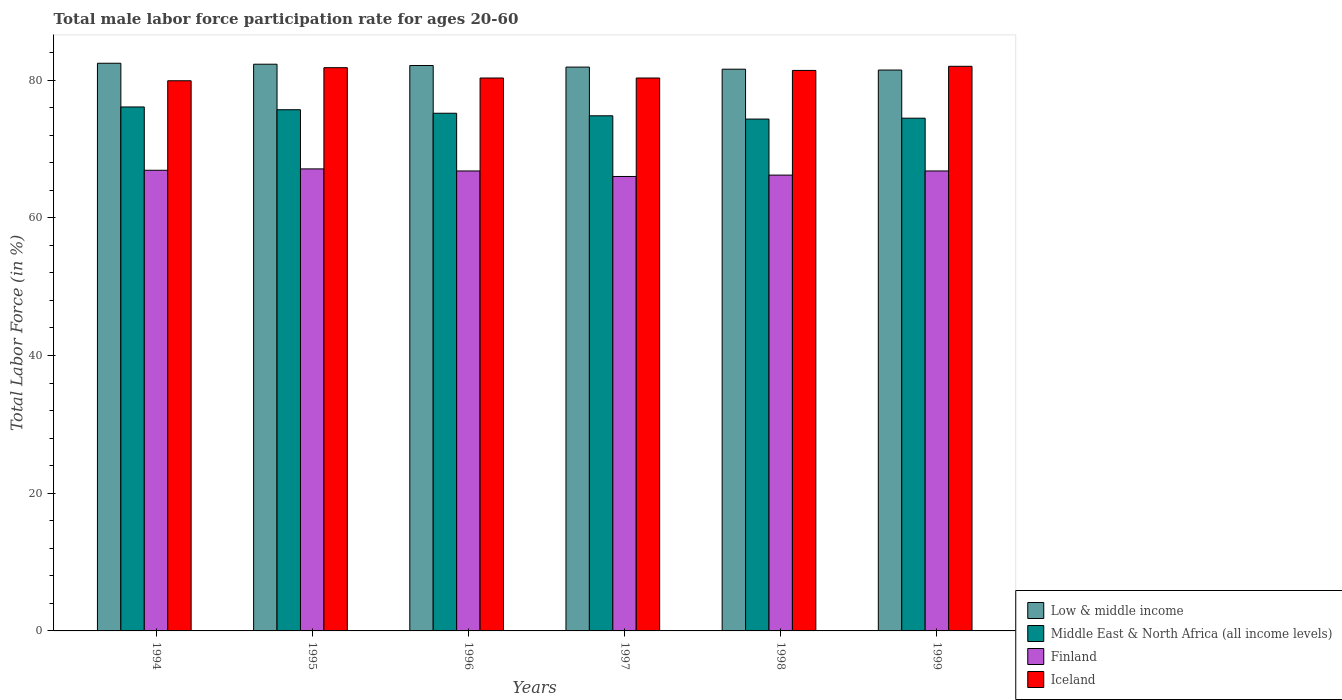How many different coloured bars are there?
Ensure brevity in your answer.  4. How many groups of bars are there?
Your response must be concise. 6. What is the male labor force participation rate in Iceland in 1997?
Offer a terse response. 80.3. Across all years, what is the maximum male labor force participation rate in Finland?
Give a very brief answer. 67.1. Across all years, what is the minimum male labor force participation rate in Iceland?
Offer a terse response. 79.9. In which year was the male labor force participation rate in Finland maximum?
Provide a short and direct response. 1995. What is the total male labor force participation rate in Middle East & North Africa (all income levels) in the graph?
Offer a terse response. 450.58. What is the difference between the male labor force participation rate in Middle East & North Africa (all income levels) in 1995 and that in 1996?
Offer a very short reply. 0.51. What is the difference between the male labor force participation rate in Middle East & North Africa (all income levels) in 1996 and the male labor force participation rate in Finland in 1995?
Offer a very short reply. 8.08. What is the average male labor force participation rate in Iceland per year?
Your answer should be compact. 80.95. In the year 1994, what is the difference between the male labor force participation rate in Iceland and male labor force participation rate in Middle East & North Africa (all income levels)?
Your response must be concise. 3.8. What is the ratio of the male labor force participation rate in Middle East & North Africa (all income levels) in 1996 to that in 1999?
Your answer should be very brief. 1.01. What is the difference between the highest and the second highest male labor force participation rate in Middle East & North Africa (all income levels)?
Provide a short and direct response. 0.4. What is the difference between the highest and the lowest male labor force participation rate in Middle East & North Africa (all income levels)?
Offer a very short reply. 1.76. Is the sum of the male labor force participation rate in Finland in 1998 and 1999 greater than the maximum male labor force participation rate in Middle East & North Africa (all income levels) across all years?
Give a very brief answer. Yes. Is it the case that in every year, the sum of the male labor force participation rate in Finland and male labor force participation rate in Iceland is greater than the sum of male labor force participation rate in Middle East & North Africa (all income levels) and male labor force participation rate in Low & middle income?
Keep it short and to the point. No. What does the 2nd bar from the left in 1995 represents?
Give a very brief answer. Middle East & North Africa (all income levels). What does the 1st bar from the right in 1996 represents?
Make the answer very short. Iceland. How many bars are there?
Ensure brevity in your answer.  24. Are all the bars in the graph horizontal?
Your response must be concise. No. How many years are there in the graph?
Give a very brief answer. 6. What is the difference between two consecutive major ticks on the Y-axis?
Make the answer very short. 20. Are the values on the major ticks of Y-axis written in scientific E-notation?
Offer a terse response. No. Does the graph contain any zero values?
Your answer should be very brief. No. Does the graph contain grids?
Offer a very short reply. No. Where does the legend appear in the graph?
Provide a succinct answer. Bottom right. How many legend labels are there?
Your answer should be compact. 4. How are the legend labels stacked?
Ensure brevity in your answer.  Vertical. What is the title of the graph?
Offer a terse response. Total male labor force participation rate for ages 20-60. Does "Uzbekistan" appear as one of the legend labels in the graph?
Provide a short and direct response. No. What is the Total Labor Force (in %) in Low & middle income in 1994?
Provide a succinct answer. 82.44. What is the Total Labor Force (in %) of Middle East & North Africa (all income levels) in 1994?
Make the answer very short. 76.1. What is the Total Labor Force (in %) of Finland in 1994?
Give a very brief answer. 66.9. What is the Total Labor Force (in %) in Iceland in 1994?
Make the answer very short. 79.9. What is the Total Labor Force (in %) of Low & middle income in 1995?
Make the answer very short. 82.3. What is the Total Labor Force (in %) in Middle East & North Africa (all income levels) in 1995?
Your answer should be compact. 75.69. What is the Total Labor Force (in %) in Finland in 1995?
Ensure brevity in your answer.  67.1. What is the Total Labor Force (in %) of Iceland in 1995?
Ensure brevity in your answer.  81.8. What is the Total Labor Force (in %) of Low & middle income in 1996?
Your answer should be compact. 82.12. What is the Total Labor Force (in %) in Middle East & North Africa (all income levels) in 1996?
Offer a very short reply. 75.18. What is the Total Labor Force (in %) of Finland in 1996?
Your response must be concise. 66.8. What is the Total Labor Force (in %) of Iceland in 1996?
Make the answer very short. 80.3. What is the Total Labor Force (in %) in Low & middle income in 1997?
Your response must be concise. 81.89. What is the Total Labor Force (in %) in Middle East & North Africa (all income levels) in 1997?
Offer a terse response. 74.81. What is the Total Labor Force (in %) in Finland in 1997?
Your response must be concise. 66. What is the Total Labor Force (in %) of Iceland in 1997?
Provide a succinct answer. 80.3. What is the Total Labor Force (in %) of Low & middle income in 1998?
Your response must be concise. 81.58. What is the Total Labor Force (in %) of Middle East & North Africa (all income levels) in 1998?
Provide a short and direct response. 74.34. What is the Total Labor Force (in %) in Finland in 1998?
Your answer should be compact. 66.2. What is the Total Labor Force (in %) of Iceland in 1998?
Provide a short and direct response. 81.4. What is the Total Labor Force (in %) in Low & middle income in 1999?
Offer a very short reply. 81.46. What is the Total Labor Force (in %) in Middle East & North Africa (all income levels) in 1999?
Offer a terse response. 74.46. What is the Total Labor Force (in %) of Finland in 1999?
Keep it short and to the point. 66.8. Across all years, what is the maximum Total Labor Force (in %) of Low & middle income?
Ensure brevity in your answer.  82.44. Across all years, what is the maximum Total Labor Force (in %) in Middle East & North Africa (all income levels)?
Give a very brief answer. 76.1. Across all years, what is the maximum Total Labor Force (in %) in Finland?
Give a very brief answer. 67.1. Across all years, what is the minimum Total Labor Force (in %) of Low & middle income?
Keep it short and to the point. 81.46. Across all years, what is the minimum Total Labor Force (in %) of Middle East & North Africa (all income levels)?
Give a very brief answer. 74.34. Across all years, what is the minimum Total Labor Force (in %) of Finland?
Your response must be concise. 66. Across all years, what is the minimum Total Labor Force (in %) in Iceland?
Your answer should be very brief. 79.9. What is the total Total Labor Force (in %) of Low & middle income in the graph?
Provide a short and direct response. 491.79. What is the total Total Labor Force (in %) in Middle East & North Africa (all income levels) in the graph?
Your answer should be compact. 450.58. What is the total Total Labor Force (in %) of Finland in the graph?
Offer a terse response. 399.8. What is the total Total Labor Force (in %) in Iceland in the graph?
Give a very brief answer. 485.7. What is the difference between the Total Labor Force (in %) in Low & middle income in 1994 and that in 1995?
Keep it short and to the point. 0.14. What is the difference between the Total Labor Force (in %) of Middle East & North Africa (all income levels) in 1994 and that in 1995?
Your answer should be compact. 0.4. What is the difference between the Total Labor Force (in %) in Finland in 1994 and that in 1995?
Your answer should be compact. -0.2. What is the difference between the Total Labor Force (in %) of Iceland in 1994 and that in 1995?
Your answer should be very brief. -1.9. What is the difference between the Total Labor Force (in %) in Low & middle income in 1994 and that in 1996?
Provide a succinct answer. 0.33. What is the difference between the Total Labor Force (in %) of Middle East & North Africa (all income levels) in 1994 and that in 1996?
Give a very brief answer. 0.91. What is the difference between the Total Labor Force (in %) in Iceland in 1994 and that in 1996?
Keep it short and to the point. -0.4. What is the difference between the Total Labor Force (in %) in Low & middle income in 1994 and that in 1997?
Your answer should be very brief. 0.56. What is the difference between the Total Labor Force (in %) of Middle East & North Africa (all income levels) in 1994 and that in 1997?
Give a very brief answer. 1.28. What is the difference between the Total Labor Force (in %) in Finland in 1994 and that in 1997?
Keep it short and to the point. 0.9. What is the difference between the Total Labor Force (in %) in Iceland in 1994 and that in 1997?
Offer a terse response. -0.4. What is the difference between the Total Labor Force (in %) in Low & middle income in 1994 and that in 1998?
Offer a terse response. 0.86. What is the difference between the Total Labor Force (in %) in Middle East & North Africa (all income levels) in 1994 and that in 1998?
Make the answer very short. 1.76. What is the difference between the Total Labor Force (in %) of Finland in 1994 and that in 1998?
Provide a short and direct response. 0.7. What is the difference between the Total Labor Force (in %) in Low & middle income in 1994 and that in 1999?
Offer a very short reply. 0.99. What is the difference between the Total Labor Force (in %) of Middle East & North Africa (all income levels) in 1994 and that in 1999?
Offer a terse response. 1.63. What is the difference between the Total Labor Force (in %) of Finland in 1994 and that in 1999?
Your answer should be compact. 0.1. What is the difference between the Total Labor Force (in %) of Low & middle income in 1995 and that in 1996?
Provide a succinct answer. 0.19. What is the difference between the Total Labor Force (in %) of Middle East & North Africa (all income levels) in 1995 and that in 1996?
Give a very brief answer. 0.51. What is the difference between the Total Labor Force (in %) in Finland in 1995 and that in 1996?
Give a very brief answer. 0.3. What is the difference between the Total Labor Force (in %) in Iceland in 1995 and that in 1996?
Provide a short and direct response. 1.5. What is the difference between the Total Labor Force (in %) of Low & middle income in 1995 and that in 1997?
Make the answer very short. 0.42. What is the difference between the Total Labor Force (in %) in Middle East & North Africa (all income levels) in 1995 and that in 1997?
Your answer should be very brief. 0.88. What is the difference between the Total Labor Force (in %) in Iceland in 1995 and that in 1997?
Offer a terse response. 1.5. What is the difference between the Total Labor Force (in %) of Low & middle income in 1995 and that in 1998?
Provide a short and direct response. 0.72. What is the difference between the Total Labor Force (in %) in Middle East & North Africa (all income levels) in 1995 and that in 1998?
Keep it short and to the point. 1.36. What is the difference between the Total Labor Force (in %) of Low & middle income in 1995 and that in 1999?
Give a very brief answer. 0.85. What is the difference between the Total Labor Force (in %) of Middle East & North Africa (all income levels) in 1995 and that in 1999?
Your answer should be very brief. 1.23. What is the difference between the Total Labor Force (in %) of Low & middle income in 1996 and that in 1997?
Keep it short and to the point. 0.23. What is the difference between the Total Labor Force (in %) of Middle East & North Africa (all income levels) in 1996 and that in 1997?
Give a very brief answer. 0.37. What is the difference between the Total Labor Force (in %) in Finland in 1996 and that in 1997?
Give a very brief answer. 0.8. What is the difference between the Total Labor Force (in %) of Iceland in 1996 and that in 1997?
Keep it short and to the point. 0. What is the difference between the Total Labor Force (in %) of Low & middle income in 1996 and that in 1998?
Your answer should be very brief. 0.54. What is the difference between the Total Labor Force (in %) in Middle East & North Africa (all income levels) in 1996 and that in 1998?
Your response must be concise. 0.85. What is the difference between the Total Labor Force (in %) of Finland in 1996 and that in 1998?
Make the answer very short. 0.6. What is the difference between the Total Labor Force (in %) of Low & middle income in 1996 and that in 1999?
Your response must be concise. 0.66. What is the difference between the Total Labor Force (in %) of Middle East & North Africa (all income levels) in 1996 and that in 1999?
Your answer should be compact. 0.72. What is the difference between the Total Labor Force (in %) of Iceland in 1996 and that in 1999?
Your answer should be compact. -1.7. What is the difference between the Total Labor Force (in %) of Low & middle income in 1997 and that in 1998?
Your response must be concise. 0.31. What is the difference between the Total Labor Force (in %) of Middle East & North Africa (all income levels) in 1997 and that in 1998?
Ensure brevity in your answer.  0.48. What is the difference between the Total Labor Force (in %) in Iceland in 1997 and that in 1998?
Make the answer very short. -1.1. What is the difference between the Total Labor Force (in %) of Low & middle income in 1997 and that in 1999?
Provide a succinct answer. 0.43. What is the difference between the Total Labor Force (in %) in Middle East & North Africa (all income levels) in 1997 and that in 1999?
Offer a very short reply. 0.35. What is the difference between the Total Labor Force (in %) of Finland in 1997 and that in 1999?
Keep it short and to the point. -0.8. What is the difference between the Total Labor Force (in %) of Iceland in 1997 and that in 1999?
Provide a succinct answer. -1.7. What is the difference between the Total Labor Force (in %) of Low & middle income in 1998 and that in 1999?
Offer a very short reply. 0.12. What is the difference between the Total Labor Force (in %) of Middle East & North Africa (all income levels) in 1998 and that in 1999?
Keep it short and to the point. -0.13. What is the difference between the Total Labor Force (in %) of Finland in 1998 and that in 1999?
Your response must be concise. -0.6. What is the difference between the Total Labor Force (in %) in Low & middle income in 1994 and the Total Labor Force (in %) in Middle East & North Africa (all income levels) in 1995?
Offer a very short reply. 6.75. What is the difference between the Total Labor Force (in %) in Low & middle income in 1994 and the Total Labor Force (in %) in Finland in 1995?
Your answer should be compact. 15.34. What is the difference between the Total Labor Force (in %) in Low & middle income in 1994 and the Total Labor Force (in %) in Iceland in 1995?
Make the answer very short. 0.64. What is the difference between the Total Labor Force (in %) of Middle East & North Africa (all income levels) in 1994 and the Total Labor Force (in %) of Finland in 1995?
Ensure brevity in your answer.  9. What is the difference between the Total Labor Force (in %) in Middle East & North Africa (all income levels) in 1994 and the Total Labor Force (in %) in Iceland in 1995?
Your answer should be very brief. -5.7. What is the difference between the Total Labor Force (in %) of Finland in 1994 and the Total Labor Force (in %) of Iceland in 1995?
Your answer should be very brief. -14.9. What is the difference between the Total Labor Force (in %) in Low & middle income in 1994 and the Total Labor Force (in %) in Middle East & North Africa (all income levels) in 1996?
Make the answer very short. 7.26. What is the difference between the Total Labor Force (in %) of Low & middle income in 1994 and the Total Labor Force (in %) of Finland in 1996?
Ensure brevity in your answer.  15.64. What is the difference between the Total Labor Force (in %) of Low & middle income in 1994 and the Total Labor Force (in %) of Iceland in 1996?
Provide a succinct answer. 2.14. What is the difference between the Total Labor Force (in %) of Middle East & North Africa (all income levels) in 1994 and the Total Labor Force (in %) of Finland in 1996?
Provide a short and direct response. 9.3. What is the difference between the Total Labor Force (in %) in Middle East & North Africa (all income levels) in 1994 and the Total Labor Force (in %) in Iceland in 1996?
Offer a terse response. -4.2. What is the difference between the Total Labor Force (in %) in Low & middle income in 1994 and the Total Labor Force (in %) in Middle East & North Africa (all income levels) in 1997?
Offer a very short reply. 7.63. What is the difference between the Total Labor Force (in %) of Low & middle income in 1994 and the Total Labor Force (in %) of Finland in 1997?
Keep it short and to the point. 16.44. What is the difference between the Total Labor Force (in %) in Low & middle income in 1994 and the Total Labor Force (in %) in Iceland in 1997?
Your answer should be very brief. 2.14. What is the difference between the Total Labor Force (in %) in Middle East & North Africa (all income levels) in 1994 and the Total Labor Force (in %) in Finland in 1997?
Ensure brevity in your answer.  10.1. What is the difference between the Total Labor Force (in %) of Middle East & North Africa (all income levels) in 1994 and the Total Labor Force (in %) of Iceland in 1997?
Give a very brief answer. -4.2. What is the difference between the Total Labor Force (in %) in Low & middle income in 1994 and the Total Labor Force (in %) in Middle East & North Africa (all income levels) in 1998?
Give a very brief answer. 8.11. What is the difference between the Total Labor Force (in %) of Low & middle income in 1994 and the Total Labor Force (in %) of Finland in 1998?
Offer a very short reply. 16.24. What is the difference between the Total Labor Force (in %) of Low & middle income in 1994 and the Total Labor Force (in %) of Iceland in 1998?
Offer a terse response. 1.04. What is the difference between the Total Labor Force (in %) of Middle East & North Africa (all income levels) in 1994 and the Total Labor Force (in %) of Finland in 1998?
Your answer should be compact. 9.9. What is the difference between the Total Labor Force (in %) of Middle East & North Africa (all income levels) in 1994 and the Total Labor Force (in %) of Iceland in 1998?
Your answer should be compact. -5.3. What is the difference between the Total Labor Force (in %) in Finland in 1994 and the Total Labor Force (in %) in Iceland in 1998?
Offer a terse response. -14.5. What is the difference between the Total Labor Force (in %) in Low & middle income in 1994 and the Total Labor Force (in %) in Middle East & North Africa (all income levels) in 1999?
Offer a terse response. 7.98. What is the difference between the Total Labor Force (in %) in Low & middle income in 1994 and the Total Labor Force (in %) in Finland in 1999?
Offer a terse response. 15.64. What is the difference between the Total Labor Force (in %) of Low & middle income in 1994 and the Total Labor Force (in %) of Iceland in 1999?
Your response must be concise. 0.44. What is the difference between the Total Labor Force (in %) in Middle East & North Africa (all income levels) in 1994 and the Total Labor Force (in %) in Finland in 1999?
Provide a succinct answer. 9.3. What is the difference between the Total Labor Force (in %) of Middle East & North Africa (all income levels) in 1994 and the Total Labor Force (in %) of Iceland in 1999?
Provide a succinct answer. -5.9. What is the difference between the Total Labor Force (in %) in Finland in 1994 and the Total Labor Force (in %) in Iceland in 1999?
Your response must be concise. -15.1. What is the difference between the Total Labor Force (in %) of Low & middle income in 1995 and the Total Labor Force (in %) of Middle East & North Africa (all income levels) in 1996?
Offer a very short reply. 7.12. What is the difference between the Total Labor Force (in %) of Low & middle income in 1995 and the Total Labor Force (in %) of Finland in 1996?
Keep it short and to the point. 15.5. What is the difference between the Total Labor Force (in %) in Low & middle income in 1995 and the Total Labor Force (in %) in Iceland in 1996?
Provide a short and direct response. 2. What is the difference between the Total Labor Force (in %) in Middle East & North Africa (all income levels) in 1995 and the Total Labor Force (in %) in Finland in 1996?
Offer a very short reply. 8.89. What is the difference between the Total Labor Force (in %) of Middle East & North Africa (all income levels) in 1995 and the Total Labor Force (in %) of Iceland in 1996?
Offer a terse response. -4.61. What is the difference between the Total Labor Force (in %) in Finland in 1995 and the Total Labor Force (in %) in Iceland in 1996?
Your answer should be compact. -13.2. What is the difference between the Total Labor Force (in %) in Low & middle income in 1995 and the Total Labor Force (in %) in Middle East & North Africa (all income levels) in 1997?
Ensure brevity in your answer.  7.49. What is the difference between the Total Labor Force (in %) of Low & middle income in 1995 and the Total Labor Force (in %) of Finland in 1997?
Your response must be concise. 16.3. What is the difference between the Total Labor Force (in %) in Low & middle income in 1995 and the Total Labor Force (in %) in Iceland in 1997?
Give a very brief answer. 2. What is the difference between the Total Labor Force (in %) in Middle East & North Africa (all income levels) in 1995 and the Total Labor Force (in %) in Finland in 1997?
Ensure brevity in your answer.  9.69. What is the difference between the Total Labor Force (in %) in Middle East & North Africa (all income levels) in 1995 and the Total Labor Force (in %) in Iceland in 1997?
Ensure brevity in your answer.  -4.61. What is the difference between the Total Labor Force (in %) of Low & middle income in 1995 and the Total Labor Force (in %) of Middle East & North Africa (all income levels) in 1998?
Provide a succinct answer. 7.97. What is the difference between the Total Labor Force (in %) in Low & middle income in 1995 and the Total Labor Force (in %) in Finland in 1998?
Offer a terse response. 16.1. What is the difference between the Total Labor Force (in %) of Low & middle income in 1995 and the Total Labor Force (in %) of Iceland in 1998?
Provide a succinct answer. 0.9. What is the difference between the Total Labor Force (in %) of Middle East & North Africa (all income levels) in 1995 and the Total Labor Force (in %) of Finland in 1998?
Keep it short and to the point. 9.49. What is the difference between the Total Labor Force (in %) of Middle East & North Africa (all income levels) in 1995 and the Total Labor Force (in %) of Iceland in 1998?
Your answer should be very brief. -5.71. What is the difference between the Total Labor Force (in %) in Finland in 1995 and the Total Labor Force (in %) in Iceland in 1998?
Give a very brief answer. -14.3. What is the difference between the Total Labor Force (in %) of Low & middle income in 1995 and the Total Labor Force (in %) of Middle East & North Africa (all income levels) in 1999?
Offer a terse response. 7.84. What is the difference between the Total Labor Force (in %) of Low & middle income in 1995 and the Total Labor Force (in %) of Finland in 1999?
Your answer should be compact. 15.5. What is the difference between the Total Labor Force (in %) in Low & middle income in 1995 and the Total Labor Force (in %) in Iceland in 1999?
Your answer should be very brief. 0.3. What is the difference between the Total Labor Force (in %) of Middle East & North Africa (all income levels) in 1995 and the Total Labor Force (in %) of Finland in 1999?
Ensure brevity in your answer.  8.89. What is the difference between the Total Labor Force (in %) of Middle East & North Africa (all income levels) in 1995 and the Total Labor Force (in %) of Iceland in 1999?
Your answer should be compact. -6.31. What is the difference between the Total Labor Force (in %) of Finland in 1995 and the Total Labor Force (in %) of Iceland in 1999?
Keep it short and to the point. -14.9. What is the difference between the Total Labor Force (in %) of Low & middle income in 1996 and the Total Labor Force (in %) of Middle East & North Africa (all income levels) in 1997?
Make the answer very short. 7.3. What is the difference between the Total Labor Force (in %) of Low & middle income in 1996 and the Total Labor Force (in %) of Finland in 1997?
Your answer should be very brief. 16.12. What is the difference between the Total Labor Force (in %) of Low & middle income in 1996 and the Total Labor Force (in %) of Iceland in 1997?
Make the answer very short. 1.82. What is the difference between the Total Labor Force (in %) in Middle East & North Africa (all income levels) in 1996 and the Total Labor Force (in %) in Finland in 1997?
Provide a short and direct response. 9.18. What is the difference between the Total Labor Force (in %) in Middle East & North Africa (all income levels) in 1996 and the Total Labor Force (in %) in Iceland in 1997?
Give a very brief answer. -5.12. What is the difference between the Total Labor Force (in %) of Low & middle income in 1996 and the Total Labor Force (in %) of Middle East & North Africa (all income levels) in 1998?
Give a very brief answer. 7.78. What is the difference between the Total Labor Force (in %) of Low & middle income in 1996 and the Total Labor Force (in %) of Finland in 1998?
Offer a very short reply. 15.92. What is the difference between the Total Labor Force (in %) in Low & middle income in 1996 and the Total Labor Force (in %) in Iceland in 1998?
Make the answer very short. 0.72. What is the difference between the Total Labor Force (in %) in Middle East & North Africa (all income levels) in 1996 and the Total Labor Force (in %) in Finland in 1998?
Your answer should be compact. 8.98. What is the difference between the Total Labor Force (in %) of Middle East & North Africa (all income levels) in 1996 and the Total Labor Force (in %) of Iceland in 1998?
Your answer should be very brief. -6.22. What is the difference between the Total Labor Force (in %) of Finland in 1996 and the Total Labor Force (in %) of Iceland in 1998?
Ensure brevity in your answer.  -14.6. What is the difference between the Total Labor Force (in %) in Low & middle income in 1996 and the Total Labor Force (in %) in Middle East & North Africa (all income levels) in 1999?
Provide a short and direct response. 7.65. What is the difference between the Total Labor Force (in %) in Low & middle income in 1996 and the Total Labor Force (in %) in Finland in 1999?
Provide a short and direct response. 15.32. What is the difference between the Total Labor Force (in %) of Low & middle income in 1996 and the Total Labor Force (in %) of Iceland in 1999?
Make the answer very short. 0.12. What is the difference between the Total Labor Force (in %) of Middle East & North Africa (all income levels) in 1996 and the Total Labor Force (in %) of Finland in 1999?
Your response must be concise. 8.38. What is the difference between the Total Labor Force (in %) of Middle East & North Africa (all income levels) in 1996 and the Total Labor Force (in %) of Iceland in 1999?
Your answer should be very brief. -6.82. What is the difference between the Total Labor Force (in %) in Finland in 1996 and the Total Labor Force (in %) in Iceland in 1999?
Give a very brief answer. -15.2. What is the difference between the Total Labor Force (in %) of Low & middle income in 1997 and the Total Labor Force (in %) of Middle East & North Africa (all income levels) in 1998?
Keep it short and to the point. 7.55. What is the difference between the Total Labor Force (in %) of Low & middle income in 1997 and the Total Labor Force (in %) of Finland in 1998?
Ensure brevity in your answer.  15.69. What is the difference between the Total Labor Force (in %) in Low & middle income in 1997 and the Total Labor Force (in %) in Iceland in 1998?
Your answer should be compact. 0.49. What is the difference between the Total Labor Force (in %) of Middle East & North Africa (all income levels) in 1997 and the Total Labor Force (in %) of Finland in 1998?
Provide a short and direct response. 8.61. What is the difference between the Total Labor Force (in %) in Middle East & North Africa (all income levels) in 1997 and the Total Labor Force (in %) in Iceland in 1998?
Keep it short and to the point. -6.59. What is the difference between the Total Labor Force (in %) of Finland in 1997 and the Total Labor Force (in %) of Iceland in 1998?
Keep it short and to the point. -15.4. What is the difference between the Total Labor Force (in %) in Low & middle income in 1997 and the Total Labor Force (in %) in Middle East & North Africa (all income levels) in 1999?
Keep it short and to the point. 7.42. What is the difference between the Total Labor Force (in %) of Low & middle income in 1997 and the Total Labor Force (in %) of Finland in 1999?
Provide a short and direct response. 15.09. What is the difference between the Total Labor Force (in %) of Low & middle income in 1997 and the Total Labor Force (in %) of Iceland in 1999?
Your answer should be very brief. -0.11. What is the difference between the Total Labor Force (in %) in Middle East & North Africa (all income levels) in 1997 and the Total Labor Force (in %) in Finland in 1999?
Offer a terse response. 8.01. What is the difference between the Total Labor Force (in %) in Middle East & North Africa (all income levels) in 1997 and the Total Labor Force (in %) in Iceland in 1999?
Provide a succinct answer. -7.19. What is the difference between the Total Labor Force (in %) of Low & middle income in 1998 and the Total Labor Force (in %) of Middle East & North Africa (all income levels) in 1999?
Offer a terse response. 7.12. What is the difference between the Total Labor Force (in %) in Low & middle income in 1998 and the Total Labor Force (in %) in Finland in 1999?
Ensure brevity in your answer.  14.78. What is the difference between the Total Labor Force (in %) in Low & middle income in 1998 and the Total Labor Force (in %) in Iceland in 1999?
Provide a short and direct response. -0.42. What is the difference between the Total Labor Force (in %) of Middle East & North Africa (all income levels) in 1998 and the Total Labor Force (in %) of Finland in 1999?
Provide a succinct answer. 7.54. What is the difference between the Total Labor Force (in %) of Middle East & North Africa (all income levels) in 1998 and the Total Labor Force (in %) of Iceland in 1999?
Your answer should be very brief. -7.66. What is the difference between the Total Labor Force (in %) of Finland in 1998 and the Total Labor Force (in %) of Iceland in 1999?
Offer a terse response. -15.8. What is the average Total Labor Force (in %) in Low & middle income per year?
Provide a short and direct response. 81.96. What is the average Total Labor Force (in %) of Middle East & North Africa (all income levels) per year?
Offer a terse response. 75.1. What is the average Total Labor Force (in %) of Finland per year?
Keep it short and to the point. 66.63. What is the average Total Labor Force (in %) of Iceland per year?
Give a very brief answer. 80.95. In the year 1994, what is the difference between the Total Labor Force (in %) of Low & middle income and Total Labor Force (in %) of Middle East & North Africa (all income levels)?
Your answer should be very brief. 6.35. In the year 1994, what is the difference between the Total Labor Force (in %) in Low & middle income and Total Labor Force (in %) in Finland?
Offer a very short reply. 15.54. In the year 1994, what is the difference between the Total Labor Force (in %) in Low & middle income and Total Labor Force (in %) in Iceland?
Keep it short and to the point. 2.54. In the year 1994, what is the difference between the Total Labor Force (in %) in Middle East & North Africa (all income levels) and Total Labor Force (in %) in Finland?
Your answer should be compact. 9.2. In the year 1994, what is the difference between the Total Labor Force (in %) of Middle East & North Africa (all income levels) and Total Labor Force (in %) of Iceland?
Keep it short and to the point. -3.8. In the year 1995, what is the difference between the Total Labor Force (in %) of Low & middle income and Total Labor Force (in %) of Middle East & North Africa (all income levels)?
Your answer should be very brief. 6.61. In the year 1995, what is the difference between the Total Labor Force (in %) in Low & middle income and Total Labor Force (in %) in Finland?
Your answer should be very brief. 15.2. In the year 1995, what is the difference between the Total Labor Force (in %) of Low & middle income and Total Labor Force (in %) of Iceland?
Offer a very short reply. 0.5. In the year 1995, what is the difference between the Total Labor Force (in %) in Middle East & North Africa (all income levels) and Total Labor Force (in %) in Finland?
Offer a terse response. 8.59. In the year 1995, what is the difference between the Total Labor Force (in %) of Middle East & North Africa (all income levels) and Total Labor Force (in %) of Iceland?
Your response must be concise. -6.11. In the year 1995, what is the difference between the Total Labor Force (in %) in Finland and Total Labor Force (in %) in Iceland?
Offer a very short reply. -14.7. In the year 1996, what is the difference between the Total Labor Force (in %) of Low & middle income and Total Labor Force (in %) of Middle East & North Africa (all income levels)?
Make the answer very short. 6.93. In the year 1996, what is the difference between the Total Labor Force (in %) of Low & middle income and Total Labor Force (in %) of Finland?
Provide a short and direct response. 15.32. In the year 1996, what is the difference between the Total Labor Force (in %) in Low & middle income and Total Labor Force (in %) in Iceland?
Offer a very short reply. 1.82. In the year 1996, what is the difference between the Total Labor Force (in %) in Middle East & North Africa (all income levels) and Total Labor Force (in %) in Finland?
Ensure brevity in your answer.  8.38. In the year 1996, what is the difference between the Total Labor Force (in %) of Middle East & North Africa (all income levels) and Total Labor Force (in %) of Iceland?
Offer a very short reply. -5.12. In the year 1996, what is the difference between the Total Labor Force (in %) of Finland and Total Labor Force (in %) of Iceland?
Keep it short and to the point. -13.5. In the year 1997, what is the difference between the Total Labor Force (in %) of Low & middle income and Total Labor Force (in %) of Middle East & North Africa (all income levels)?
Make the answer very short. 7.07. In the year 1997, what is the difference between the Total Labor Force (in %) of Low & middle income and Total Labor Force (in %) of Finland?
Keep it short and to the point. 15.89. In the year 1997, what is the difference between the Total Labor Force (in %) of Low & middle income and Total Labor Force (in %) of Iceland?
Offer a terse response. 1.59. In the year 1997, what is the difference between the Total Labor Force (in %) in Middle East & North Africa (all income levels) and Total Labor Force (in %) in Finland?
Offer a very short reply. 8.81. In the year 1997, what is the difference between the Total Labor Force (in %) of Middle East & North Africa (all income levels) and Total Labor Force (in %) of Iceland?
Provide a succinct answer. -5.49. In the year 1997, what is the difference between the Total Labor Force (in %) of Finland and Total Labor Force (in %) of Iceland?
Offer a very short reply. -14.3. In the year 1998, what is the difference between the Total Labor Force (in %) in Low & middle income and Total Labor Force (in %) in Middle East & North Africa (all income levels)?
Offer a very short reply. 7.24. In the year 1998, what is the difference between the Total Labor Force (in %) in Low & middle income and Total Labor Force (in %) in Finland?
Keep it short and to the point. 15.38. In the year 1998, what is the difference between the Total Labor Force (in %) in Low & middle income and Total Labor Force (in %) in Iceland?
Offer a very short reply. 0.18. In the year 1998, what is the difference between the Total Labor Force (in %) in Middle East & North Africa (all income levels) and Total Labor Force (in %) in Finland?
Ensure brevity in your answer.  8.14. In the year 1998, what is the difference between the Total Labor Force (in %) of Middle East & North Africa (all income levels) and Total Labor Force (in %) of Iceland?
Make the answer very short. -7.06. In the year 1998, what is the difference between the Total Labor Force (in %) of Finland and Total Labor Force (in %) of Iceland?
Ensure brevity in your answer.  -15.2. In the year 1999, what is the difference between the Total Labor Force (in %) of Low & middle income and Total Labor Force (in %) of Middle East & North Africa (all income levels)?
Give a very brief answer. 6.99. In the year 1999, what is the difference between the Total Labor Force (in %) in Low & middle income and Total Labor Force (in %) in Finland?
Your response must be concise. 14.66. In the year 1999, what is the difference between the Total Labor Force (in %) in Low & middle income and Total Labor Force (in %) in Iceland?
Offer a terse response. -0.54. In the year 1999, what is the difference between the Total Labor Force (in %) of Middle East & North Africa (all income levels) and Total Labor Force (in %) of Finland?
Provide a short and direct response. 7.66. In the year 1999, what is the difference between the Total Labor Force (in %) of Middle East & North Africa (all income levels) and Total Labor Force (in %) of Iceland?
Offer a terse response. -7.54. In the year 1999, what is the difference between the Total Labor Force (in %) in Finland and Total Labor Force (in %) in Iceland?
Your answer should be very brief. -15.2. What is the ratio of the Total Labor Force (in %) in Iceland in 1994 to that in 1995?
Keep it short and to the point. 0.98. What is the ratio of the Total Labor Force (in %) in Middle East & North Africa (all income levels) in 1994 to that in 1996?
Provide a succinct answer. 1.01. What is the ratio of the Total Labor Force (in %) in Finland in 1994 to that in 1996?
Ensure brevity in your answer.  1. What is the ratio of the Total Labor Force (in %) of Low & middle income in 1994 to that in 1997?
Provide a succinct answer. 1.01. What is the ratio of the Total Labor Force (in %) of Middle East & North Africa (all income levels) in 1994 to that in 1997?
Keep it short and to the point. 1.02. What is the ratio of the Total Labor Force (in %) in Finland in 1994 to that in 1997?
Offer a terse response. 1.01. What is the ratio of the Total Labor Force (in %) of Iceland in 1994 to that in 1997?
Provide a short and direct response. 0.99. What is the ratio of the Total Labor Force (in %) in Low & middle income in 1994 to that in 1998?
Provide a succinct answer. 1.01. What is the ratio of the Total Labor Force (in %) of Middle East & North Africa (all income levels) in 1994 to that in 1998?
Provide a short and direct response. 1.02. What is the ratio of the Total Labor Force (in %) in Finland in 1994 to that in 1998?
Make the answer very short. 1.01. What is the ratio of the Total Labor Force (in %) of Iceland in 1994 to that in 1998?
Make the answer very short. 0.98. What is the ratio of the Total Labor Force (in %) of Low & middle income in 1994 to that in 1999?
Provide a succinct answer. 1.01. What is the ratio of the Total Labor Force (in %) of Middle East & North Africa (all income levels) in 1994 to that in 1999?
Ensure brevity in your answer.  1.02. What is the ratio of the Total Labor Force (in %) of Finland in 1994 to that in 1999?
Make the answer very short. 1. What is the ratio of the Total Labor Force (in %) in Iceland in 1994 to that in 1999?
Provide a short and direct response. 0.97. What is the ratio of the Total Labor Force (in %) in Low & middle income in 1995 to that in 1996?
Keep it short and to the point. 1. What is the ratio of the Total Labor Force (in %) of Middle East & North Africa (all income levels) in 1995 to that in 1996?
Ensure brevity in your answer.  1.01. What is the ratio of the Total Labor Force (in %) in Finland in 1995 to that in 1996?
Provide a short and direct response. 1. What is the ratio of the Total Labor Force (in %) in Iceland in 1995 to that in 1996?
Give a very brief answer. 1.02. What is the ratio of the Total Labor Force (in %) in Middle East & North Africa (all income levels) in 1995 to that in 1997?
Offer a terse response. 1.01. What is the ratio of the Total Labor Force (in %) of Finland in 1995 to that in 1997?
Make the answer very short. 1.02. What is the ratio of the Total Labor Force (in %) in Iceland in 1995 to that in 1997?
Ensure brevity in your answer.  1.02. What is the ratio of the Total Labor Force (in %) in Low & middle income in 1995 to that in 1998?
Provide a succinct answer. 1.01. What is the ratio of the Total Labor Force (in %) in Middle East & North Africa (all income levels) in 1995 to that in 1998?
Offer a terse response. 1.02. What is the ratio of the Total Labor Force (in %) of Finland in 1995 to that in 1998?
Give a very brief answer. 1.01. What is the ratio of the Total Labor Force (in %) of Low & middle income in 1995 to that in 1999?
Provide a succinct answer. 1.01. What is the ratio of the Total Labor Force (in %) in Middle East & North Africa (all income levels) in 1995 to that in 1999?
Your answer should be compact. 1.02. What is the ratio of the Total Labor Force (in %) of Iceland in 1995 to that in 1999?
Make the answer very short. 1. What is the ratio of the Total Labor Force (in %) in Low & middle income in 1996 to that in 1997?
Offer a very short reply. 1. What is the ratio of the Total Labor Force (in %) of Finland in 1996 to that in 1997?
Your answer should be very brief. 1.01. What is the ratio of the Total Labor Force (in %) of Iceland in 1996 to that in 1997?
Make the answer very short. 1. What is the ratio of the Total Labor Force (in %) of Low & middle income in 1996 to that in 1998?
Your response must be concise. 1.01. What is the ratio of the Total Labor Force (in %) in Middle East & North Africa (all income levels) in 1996 to that in 1998?
Ensure brevity in your answer.  1.01. What is the ratio of the Total Labor Force (in %) of Finland in 1996 to that in 1998?
Provide a short and direct response. 1.01. What is the ratio of the Total Labor Force (in %) of Iceland in 1996 to that in 1998?
Keep it short and to the point. 0.99. What is the ratio of the Total Labor Force (in %) in Low & middle income in 1996 to that in 1999?
Provide a short and direct response. 1.01. What is the ratio of the Total Labor Force (in %) in Middle East & North Africa (all income levels) in 1996 to that in 1999?
Give a very brief answer. 1.01. What is the ratio of the Total Labor Force (in %) in Iceland in 1996 to that in 1999?
Ensure brevity in your answer.  0.98. What is the ratio of the Total Labor Force (in %) in Low & middle income in 1997 to that in 1998?
Give a very brief answer. 1. What is the ratio of the Total Labor Force (in %) of Middle East & North Africa (all income levels) in 1997 to that in 1998?
Your answer should be very brief. 1.01. What is the ratio of the Total Labor Force (in %) in Finland in 1997 to that in 1998?
Your answer should be very brief. 1. What is the ratio of the Total Labor Force (in %) of Iceland in 1997 to that in 1998?
Your response must be concise. 0.99. What is the ratio of the Total Labor Force (in %) in Low & middle income in 1997 to that in 1999?
Provide a succinct answer. 1.01. What is the ratio of the Total Labor Force (in %) of Iceland in 1997 to that in 1999?
Your response must be concise. 0.98. What is the difference between the highest and the second highest Total Labor Force (in %) in Low & middle income?
Ensure brevity in your answer.  0.14. What is the difference between the highest and the second highest Total Labor Force (in %) in Middle East & North Africa (all income levels)?
Your answer should be very brief. 0.4. What is the difference between the highest and the lowest Total Labor Force (in %) of Low & middle income?
Keep it short and to the point. 0.99. What is the difference between the highest and the lowest Total Labor Force (in %) of Middle East & North Africa (all income levels)?
Your answer should be compact. 1.76. What is the difference between the highest and the lowest Total Labor Force (in %) in Finland?
Your response must be concise. 1.1. 